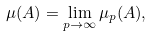Convert formula to latex. <formula><loc_0><loc_0><loc_500><loc_500>\mu ( A ) = \lim _ { p \to \infty } \mu _ { p } ( A ) ,</formula> 